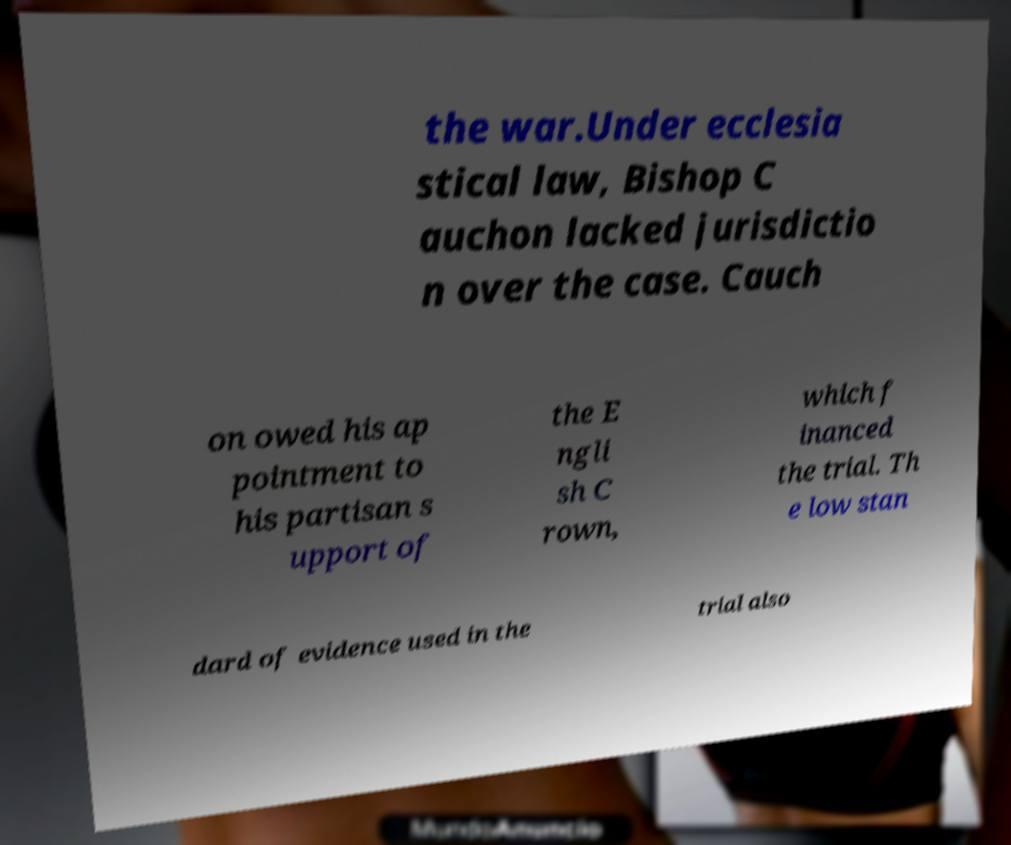Can you accurately transcribe the text from the provided image for me? the war.Under ecclesia stical law, Bishop C auchon lacked jurisdictio n over the case. Cauch on owed his ap pointment to his partisan s upport of the E ngli sh C rown, which f inanced the trial. Th e low stan dard of evidence used in the trial also 